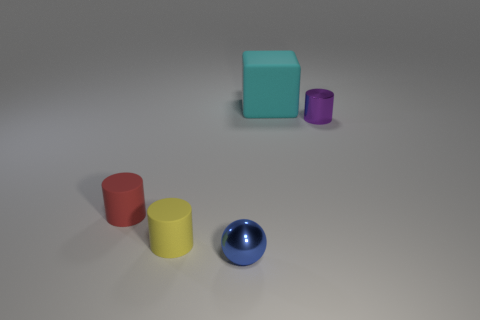Subtract all purple cylinders. How many cylinders are left? 2 Add 5 small purple things. How many objects exist? 10 Subtract all yellow cylinders. How many cylinders are left? 2 Subtract 1 blue balls. How many objects are left? 4 Subtract all cubes. How many objects are left? 4 Subtract 1 cylinders. How many cylinders are left? 2 Subtract all green balls. Subtract all purple blocks. How many balls are left? 1 Subtract all small blue balls. Subtract all matte objects. How many objects are left? 1 Add 3 tiny red things. How many tiny red things are left? 4 Add 5 tiny purple cylinders. How many tiny purple cylinders exist? 6 